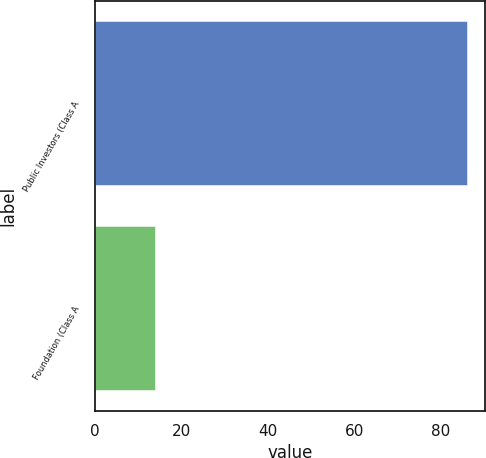<chart> <loc_0><loc_0><loc_500><loc_500><bar_chart><fcel>Public Investors (Class A<fcel>Foundation (Class A<nl><fcel>86<fcel>14<nl></chart> 